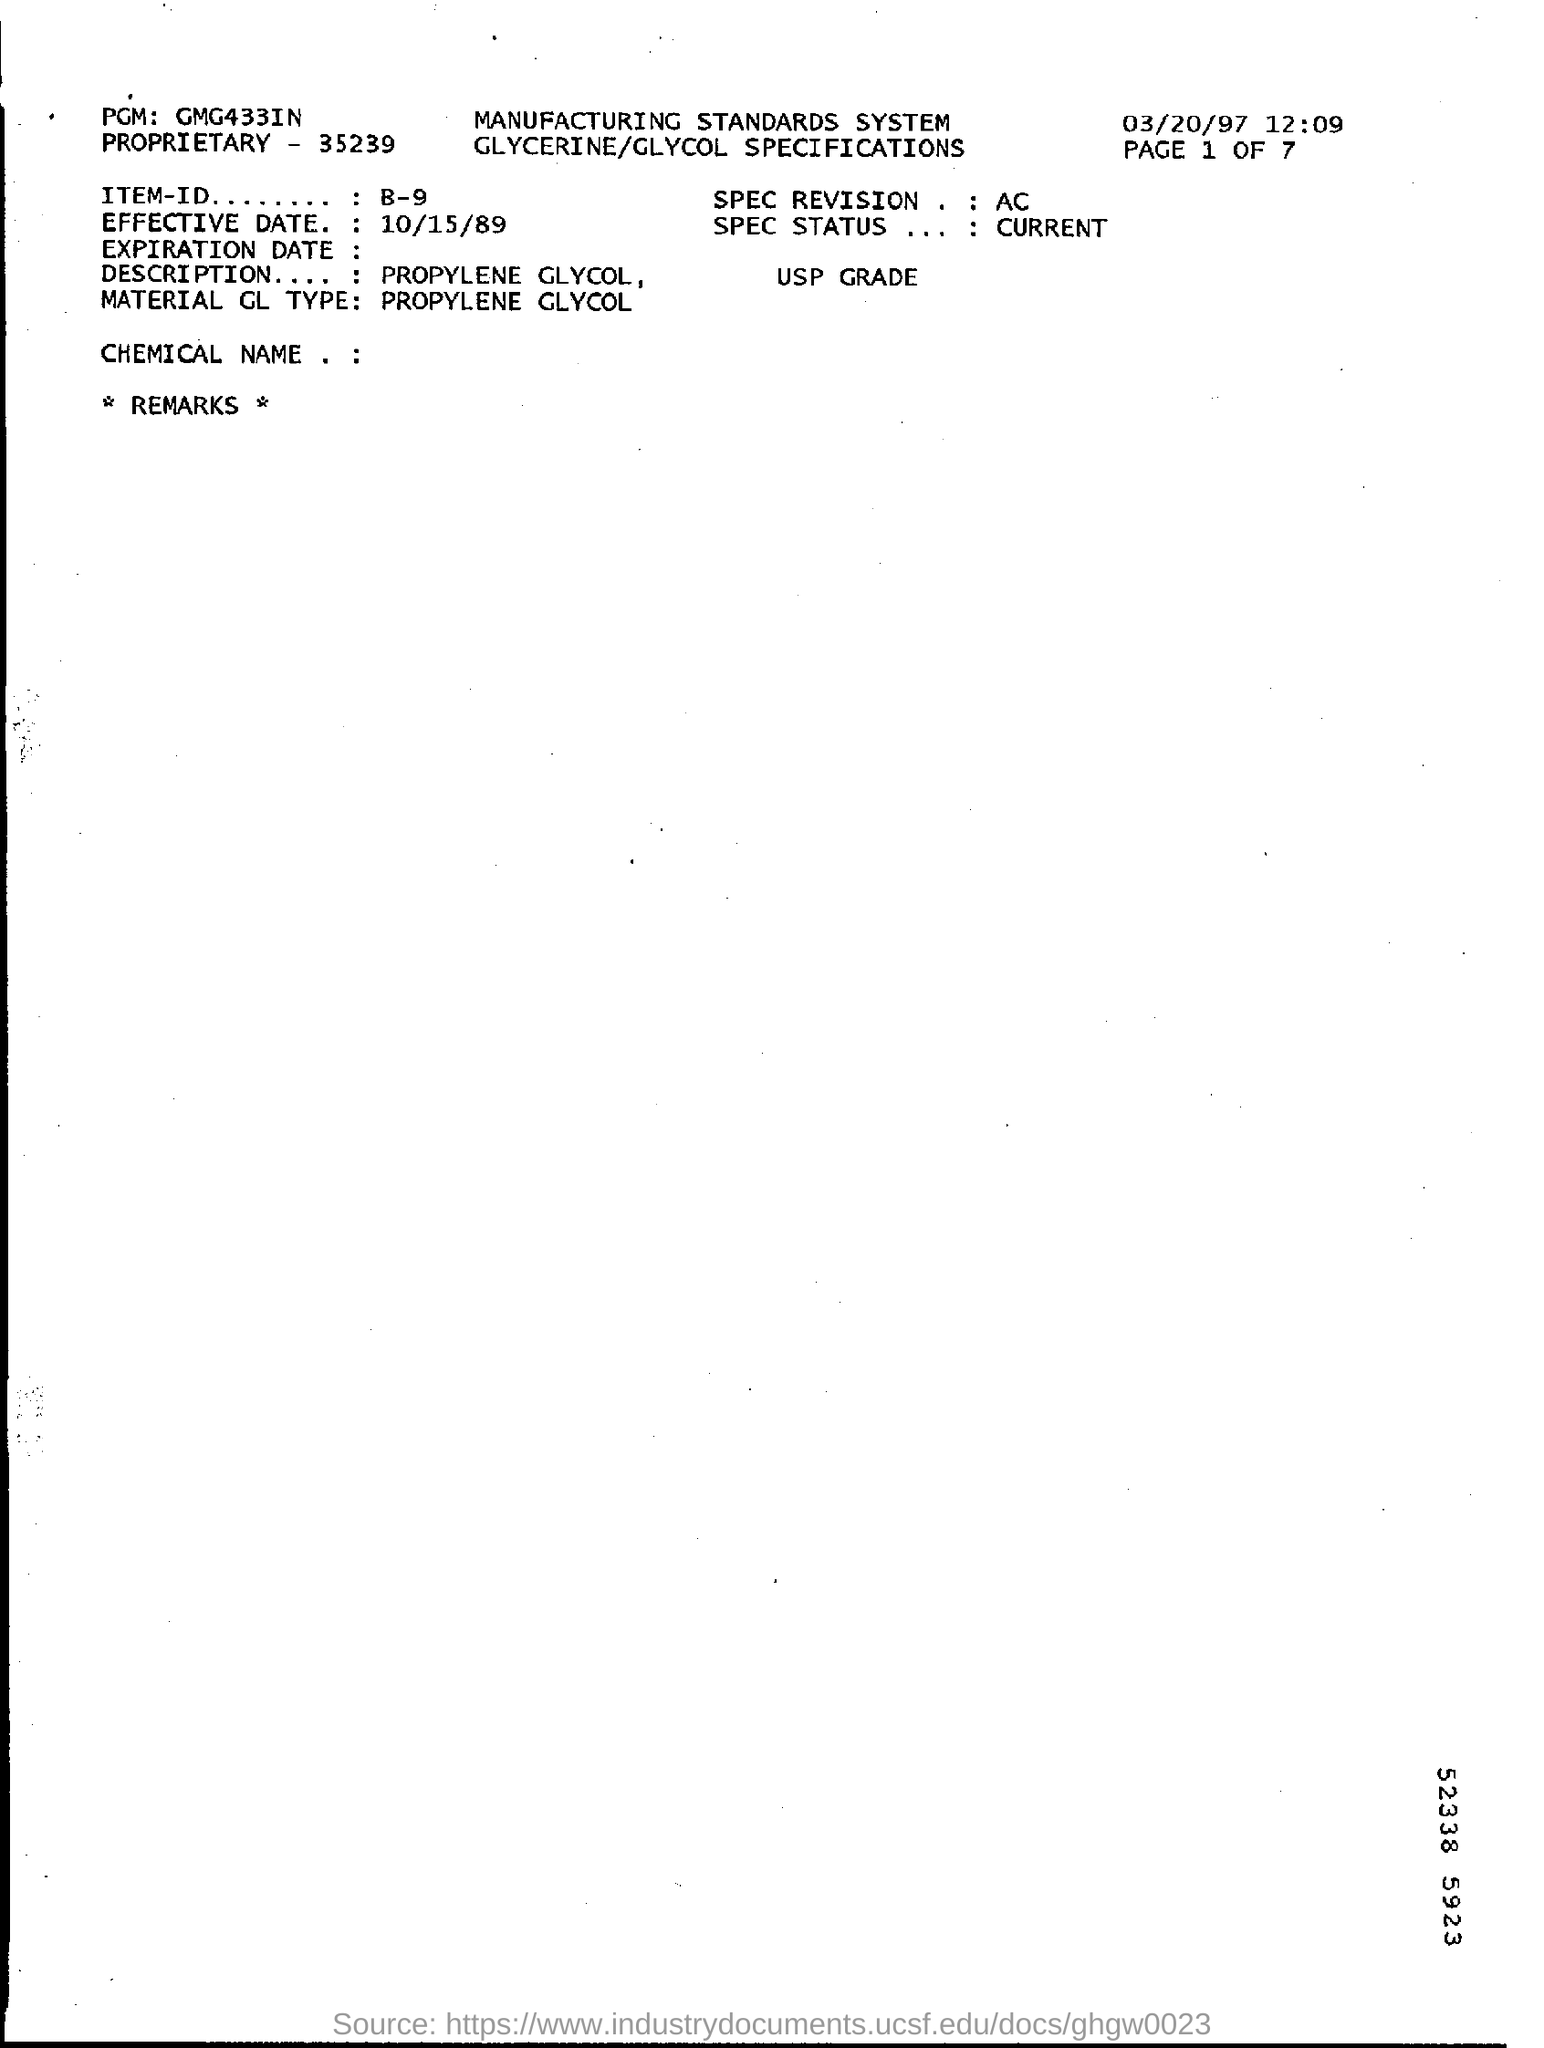What is the date mentioned in the top right of the document ?
Offer a terse response. 03/20/97. What is the Proprietary Number ?
Give a very brief answer. 35239. What is the Effective Date  ?
Offer a very short reply. 10/15/89. What is the Item ID ?
Ensure brevity in your answer.  B-9. What is mentioned in the Description Field ?
Your answer should be very brief. Propylene glycol, usp grade. What is written in the SPEC REVISION Field ?
Ensure brevity in your answer.  AC. What is mentioned in the PGM Filed ?
Provide a succinct answer. GMG433IN. What is Written in the SPEC Status Field ?
Provide a succinct answer. Current. 